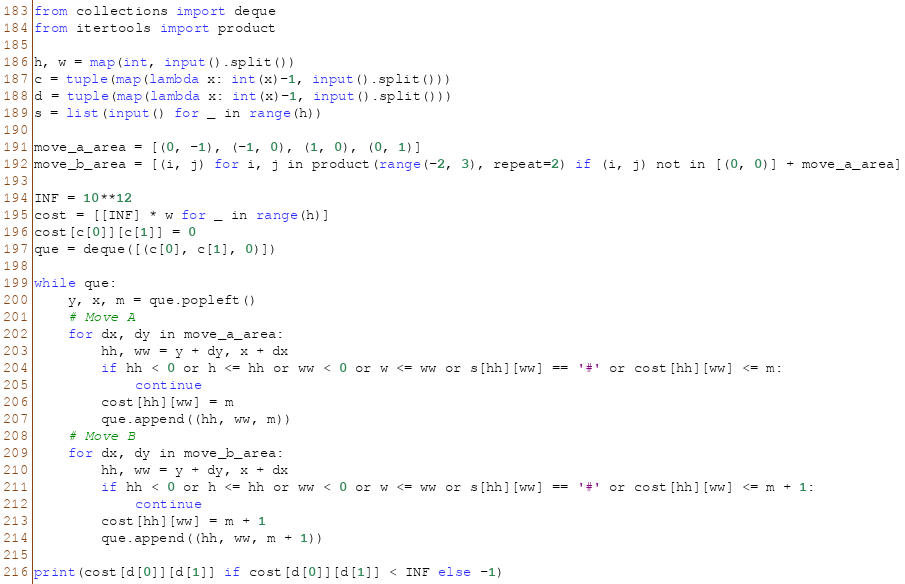<code> <loc_0><loc_0><loc_500><loc_500><_Python_>from collections import deque
from itertools import product

h, w = map(int, input().split())
c = tuple(map(lambda x: int(x)-1, input().split()))
d = tuple(map(lambda x: int(x)-1, input().split()))
s = list(input() for _ in range(h))

move_a_area = [(0, -1), (-1, 0), (1, 0), (0, 1)]
move_b_area = [(i, j) for i, j in product(range(-2, 3), repeat=2) if (i, j) not in [(0, 0)] + move_a_area]

INF = 10**12
cost = [[INF] * w for _ in range(h)]
cost[c[0]][c[1]] = 0
que = deque([(c[0], c[1], 0)])

while que:
    y, x, m = que.popleft()
    # Move A
    for dx, dy in move_a_area:
        hh, ww = y + dy, x + dx
        if hh < 0 or h <= hh or ww < 0 or w <= ww or s[hh][ww] == '#' or cost[hh][ww] <= m:
            continue
        cost[hh][ww] = m
        que.append((hh, ww, m))
    # Move B
    for dx, dy in move_b_area:
        hh, ww = y + dy, x + dx
        if hh < 0 or h <= hh or ww < 0 or w <= ww or s[hh][ww] == '#' or cost[hh][ww] <= m + 1:
            continue
        cost[hh][ww] = m + 1
        que.append((hh, ww, m + 1))

print(cost[d[0]][d[1]] if cost[d[0]][d[1]] < INF else -1)
</code> 